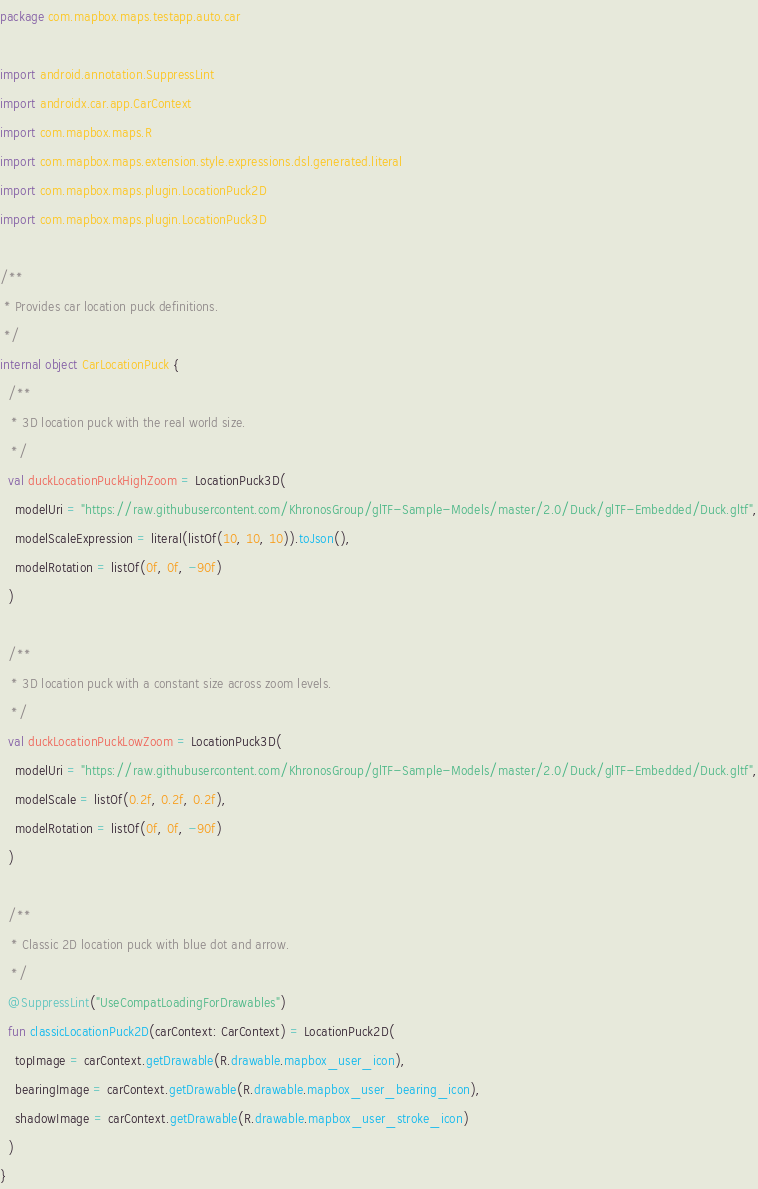<code> <loc_0><loc_0><loc_500><loc_500><_Kotlin_>package com.mapbox.maps.testapp.auto.car

import android.annotation.SuppressLint
import androidx.car.app.CarContext
import com.mapbox.maps.R
import com.mapbox.maps.extension.style.expressions.dsl.generated.literal
import com.mapbox.maps.plugin.LocationPuck2D
import com.mapbox.maps.plugin.LocationPuck3D

/**
 * Provides car location puck definitions.
 */
internal object CarLocationPuck {
  /**
   * 3D location puck with the real world size.
   */
  val duckLocationPuckHighZoom = LocationPuck3D(
    modelUri = "https://raw.githubusercontent.com/KhronosGroup/glTF-Sample-Models/master/2.0/Duck/glTF-Embedded/Duck.gltf",
    modelScaleExpression = literal(listOf(10, 10, 10)).toJson(),
    modelRotation = listOf(0f, 0f, -90f)
  )

  /**
   * 3D location puck with a constant size across zoom levels.
   */
  val duckLocationPuckLowZoom = LocationPuck3D(
    modelUri = "https://raw.githubusercontent.com/KhronosGroup/glTF-Sample-Models/master/2.0/Duck/glTF-Embedded/Duck.gltf",
    modelScale = listOf(0.2f, 0.2f, 0.2f),
    modelRotation = listOf(0f, 0f, -90f)
  )

  /**
   * Classic 2D location puck with blue dot and arrow.
   */
  @SuppressLint("UseCompatLoadingForDrawables")
  fun classicLocationPuck2D(carContext: CarContext) = LocationPuck2D(
    topImage = carContext.getDrawable(R.drawable.mapbox_user_icon),
    bearingImage = carContext.getDrawable(R.drawable.mapbox_user_bearing_icon),
    shadowImage = carContext.getDrawable(R.drawable.mapbox_user_stroke_icon)
  )
}</code> 